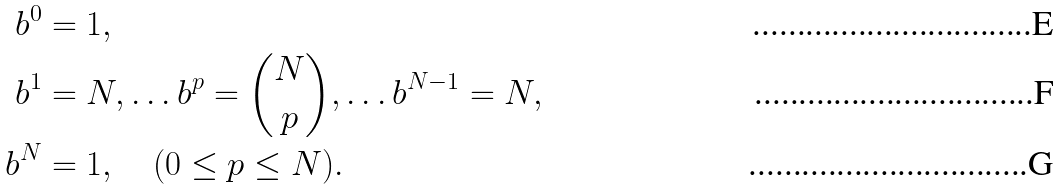Convert formula to latex. <formula><loc_0><loc_0><loc_500><loc_500>b ^ { 0 } & = 1 , \, \\ b ^ { 1 } & = N , \dots b ^ { p } = { \binom { N } { p } } , \dots b ^ { N - 1 } = N , \\ b ^ { N } & = 1 , \quad ( 0 \leq p \leq N ) .</formula> 